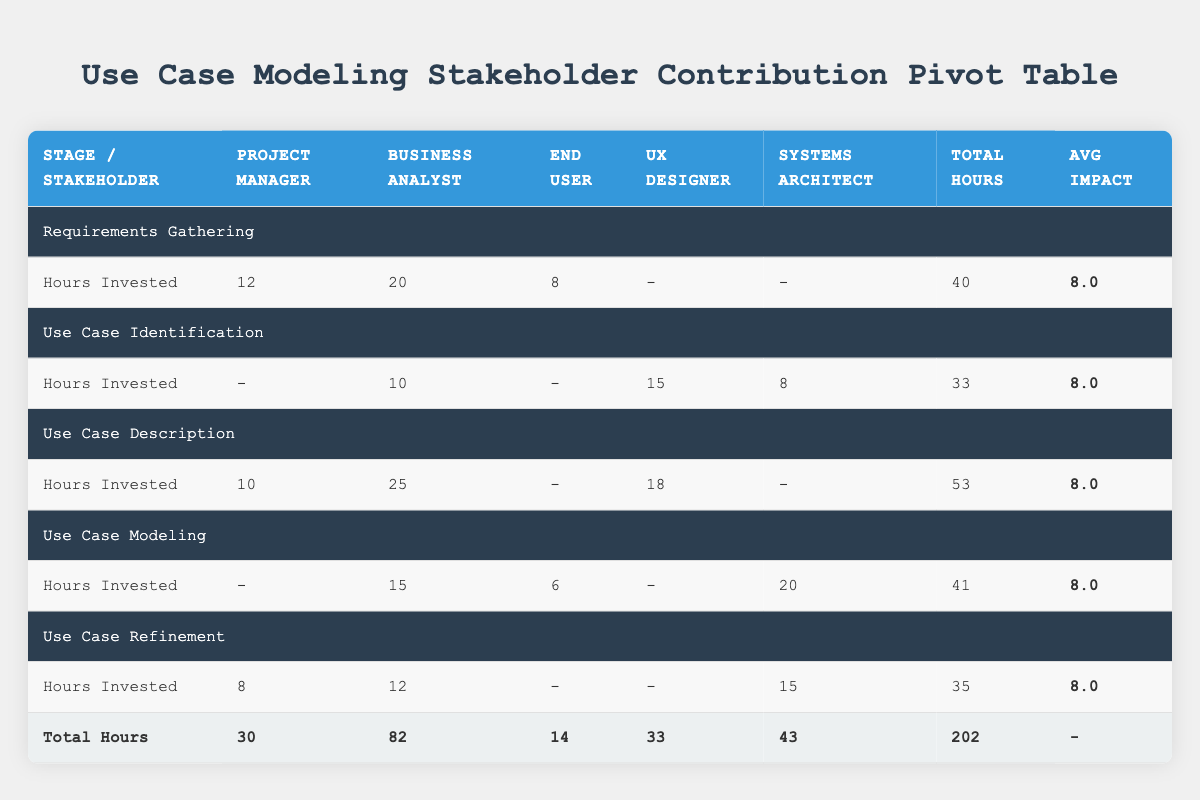What is the total number of hours invested by the Systems Architect? From the table, we can see the contributions of the Systems Architect across different stages: Use Case Identification (8 hours), Use Case Refinement (15 hours), and Use Case Modeling (20 hours). Adding these together gives us a total of 8 + 15 + 20 = 43 hours.
Answer: 43 Who invested the most hours in Use Case Description? The Business Analyst invested 25 hours in Use Case Description, while the UX Designer invested 18 hours and the Project Manager invested 10 hours. Thus, the Business Analyst is the one who invested the most hours in this stage.
Answer: Business Analyst What is the average impact score across all stages for the End User? The End User’s impact scores are 7 (Requirements Gathering), 7 (Use Case Modeling), and there are no contributions in other stages, so we only have those two scores. To get the average, we add these scores: 7 + 7 = 14 and then divide by the total number of contributions (2), which gives us an average impact score of 14 / 2 = 7.
Answer: 7 Did the Project Manager contribute in every stage? By examining the table, we see that the Project Manager contributed in Requirements Gathering, Use Case Description, and Use Case Refinement, but not in Use Case Identification or Use Case Modeling. Therefore, the Project Manager did not contribute in every stage.
Answer: No What is the total hours invested by each stakeholder? The total hours can be gathered by looking at each stakeholder's contributions: Project Manager (30 hours), Business Analyst (82 hours), End User (14 hours), UX Designer (33 hours), and Systems Architect (43 hours). Thus, the totals are 30 + 82 + 14 + 33 + 43 = 202 hours overall, and individual contributions can be seen for a clearer view.
Answer: 202 Which stakeholder had the highest total impact score in Requirements Gathering? In Requirements Gathering, the impact scores are as follows: Project Manager (9), Business Analyst (8), and End User (7). The Project Manager had the highest impact score, with a score of 9.
Answer: Project Manager How many total hours were invested in the Use Case Modeling stage? For the Use Case Modeling stage, the hours invested are: Systems Architect (20), Business Analyst (15), and End User (6). When we sum these investments, we get 20 + 15 + 6 = 41 hours invested in this stage.
Answer: 41 Is the average impact score for Use Case Identification higher than 8? The average impact score for Use Case Identification can be calculated using the contributions: UX Designer (7), Business Analyst (8), and Systems Architect (9). Adding these scores gives us 7 + 8 + 9 = 24, and dividing by the total contributions (3) equals an average of 24 / 3 = 8. Therefore, the average impact score is not higher than 8.
Answer: No 